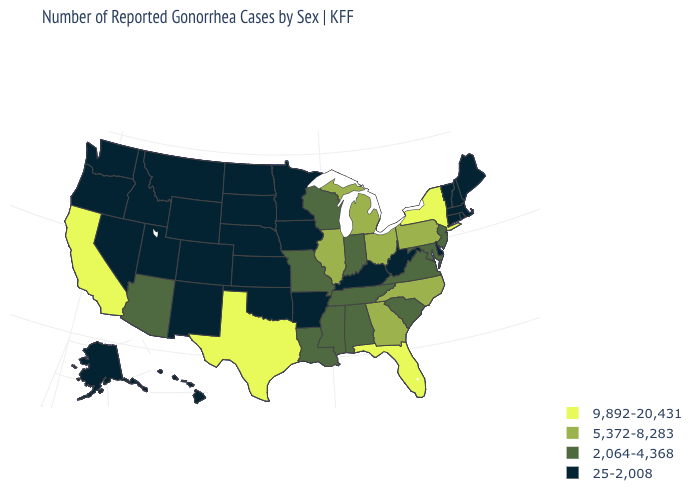What is the highest value in the USA?
Keep it brief. 9,892-20,431. What is the value of Vermont?
Be succinct. 25-2,008. Which states have the lowest value in the Northeast?
Give a very brief answer. Connecticut, Maine, Massachusetts, New Hampshire, Rhode Island, Vermont. Name the states that have a value in the range 5,372-8,283?
Concise answer only. Georgia, Illinois, Michigan, North Carolina, Ohio, Pennsylvania. Name the states that have a value in the range 2,064-4,368?
Be succinct. Alabama, Arizona, Indiana, Louisiana, Maryland, Mississippi, Missouri, New Jersey, South Carolina, Tennessee, Virginia, Wisconsin. What is the value of Oklahoma?
Concise answer only. 25-2,008. Name the states that have a value in the range 25-2,008?
Keep it brief. Alaska, Arkansas, Colorado, Connecticut, Delaware, Hawaii, Idaho, Iowa, Kansas, Kentucky, Maine, Massachusetts, Minnesota, Montana, Nebraska, Nevada, New Hampshire, New Mexico, North Dakota, Oklahoma, Oregon, Rhode Island, South Dakota, Utah, Vermont, Washington, West Virginia, Wyoming. Does Connecticut have the highest value in the Northeast?
Write a very short answer. No. Which states have the lowest value in the West?
Short answer required. Alaska, Colorado, Hawaii, Idaho, Montana, Nevada, New Mexico, Oregon, Utah, Washington, Wyoming. What is the value of Michigan?
Write a very short answer. 5,372-8,283. Name the states that have a value in the range 25-2,008?
Concise answer only. Alaska, Arkansas, Colorado, Connecticut, Delaware, Hawaii, Idaho, Iowa, Kansas, Kentucky, Maine, Massachusetts, Minnesota, Montana, Nebraska, Nevada, New Hampshire, New Mexico, North Dakota, Oklahoma, Oregon, Rhode Island, South Dakota, Utah, Vermont, Washington, West Virginia, Wyoming. Does the map have missing data?
Short answer required. No. What is the lowest value in the Northeast?
Keep it brief. 25-2,008. How many symbols are there in the legend?
Keep it brief. 4. 